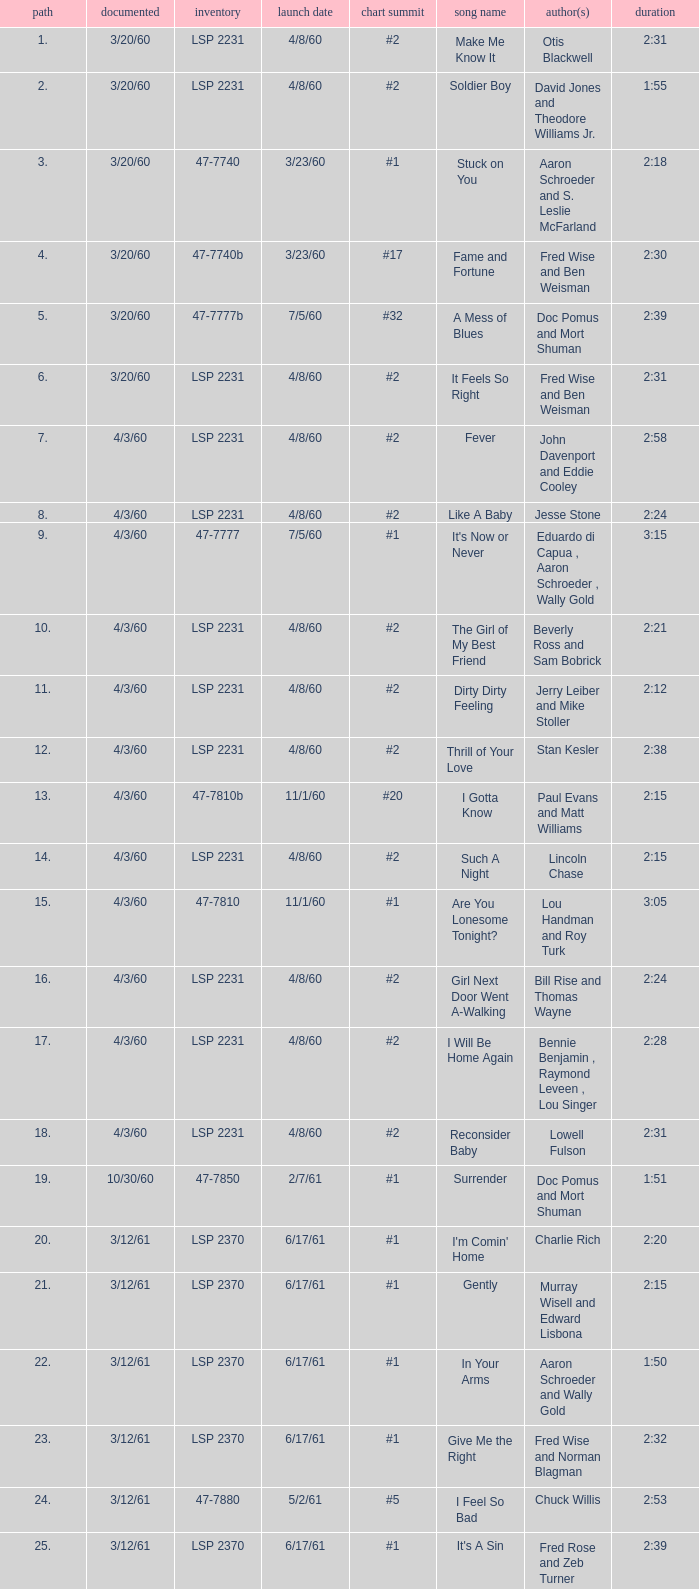What is the time of songs that have the writer Aaron Schroeder and Wally Gold? 1:50. 